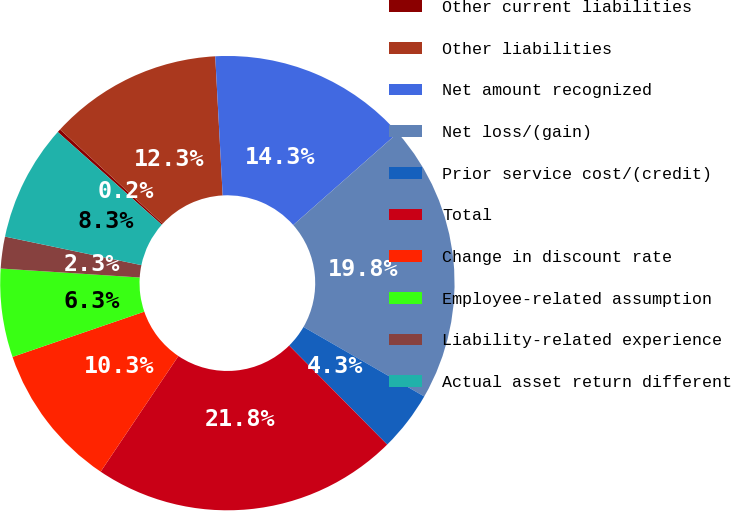Convert chart. <chart><loc_0><loc_0><loc_500><loc_500><pie_chart><fcel>Other current liabilities<fcel>Other liabilities<fcel>Net amount recognized<fcel>Net loss/(gain)<fcel>Prior service cost/(credit)<fcel>Total<fcel>Change in discount rate<fcel>Employee-related assumption<fcel>Liability-related experience<fcel>Actual asset return different<nl><fcel>0.24%<fcel>12.33%<fcel>14.35%<fcel>19.82%<fcel>4.27%<fcel>21.84%<fcel>10.32%<fcel>6.29%<fcel>2.26%<fcel>8.3%<nl></chart> 